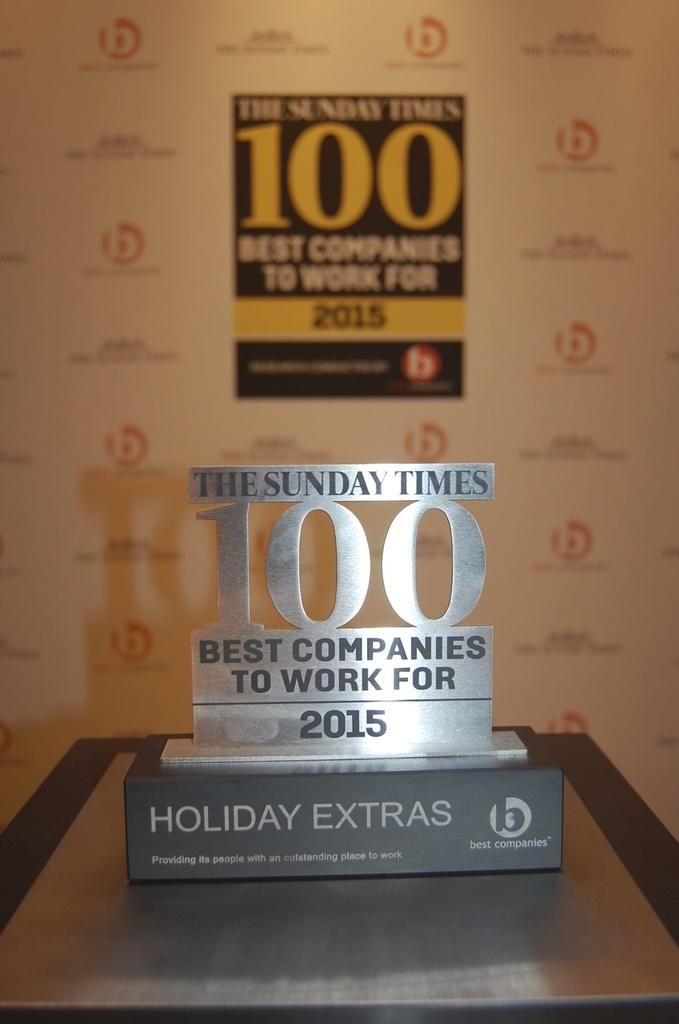Provide a one-sentence caption for the provided image. The plaque indicates The Sunday Times is one of the best companies to work for. 